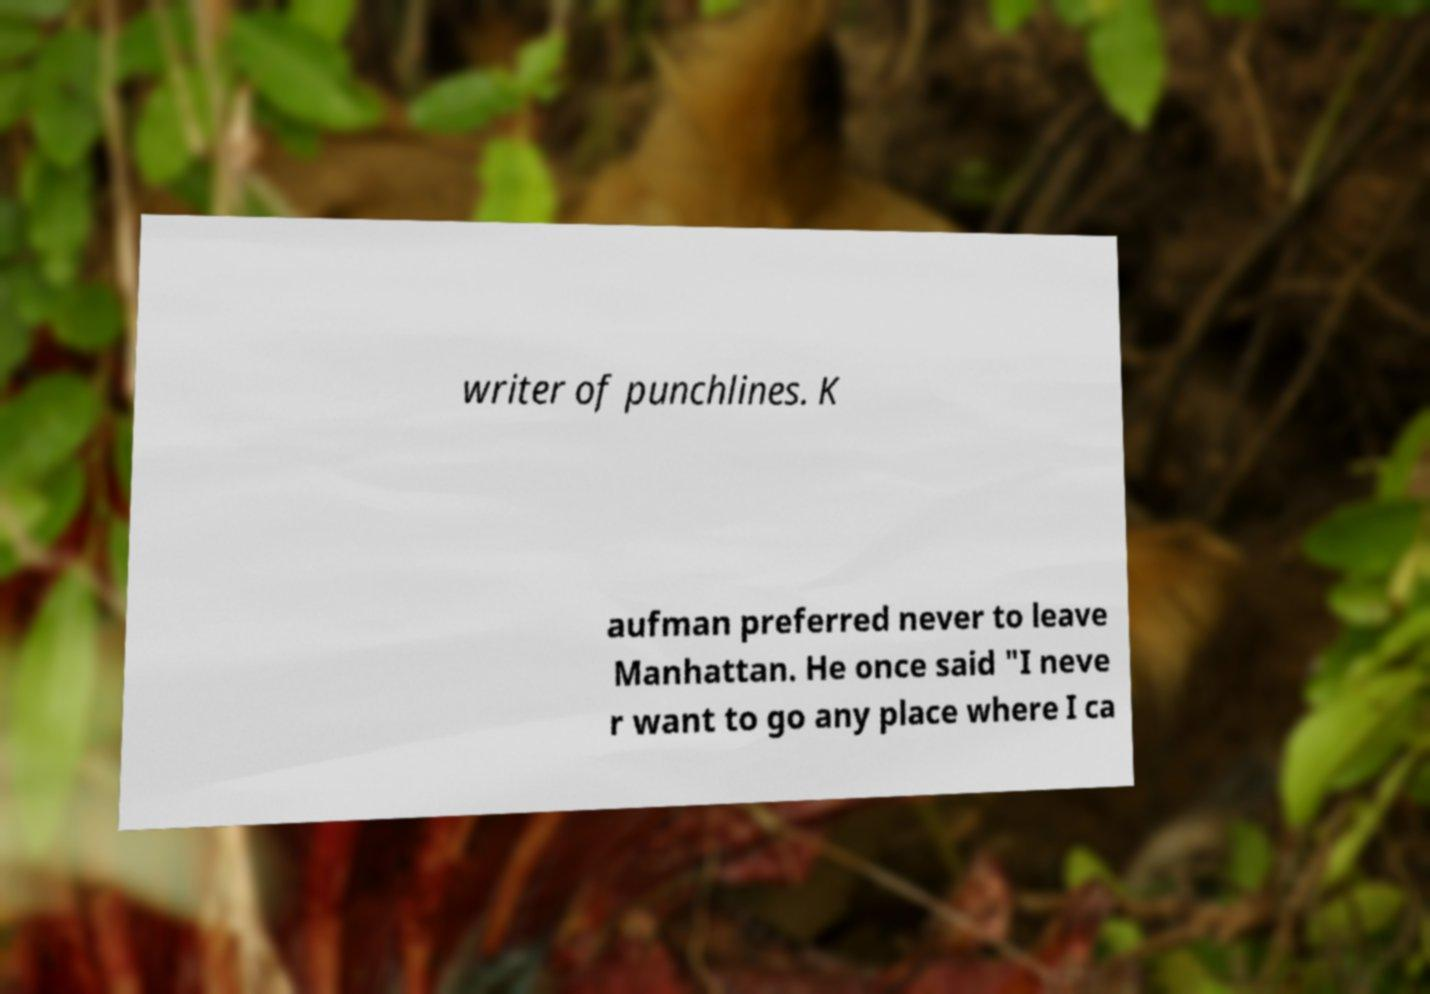What messages or text are displayed in this image? I need them in a readable, typed format. writer of punchlines. K aufman preferred never to leave Manhattan. He once said "I neve r want to go any place where I ca 